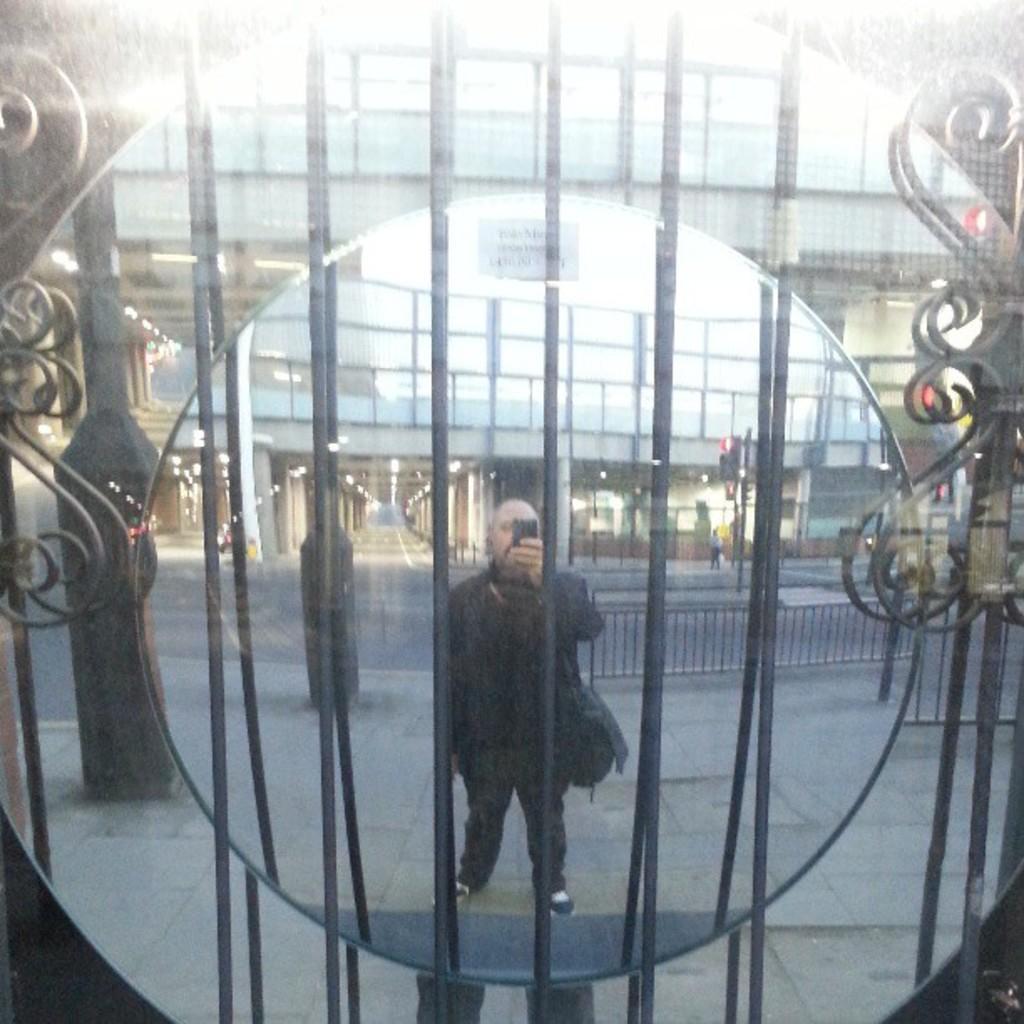Describe this image in one or two sentences. In this picture there is a mirror, in the mirror we can see the reflection of designed iron frame and there is a person in black dress holding an object and there are buildings, roads and railing. 